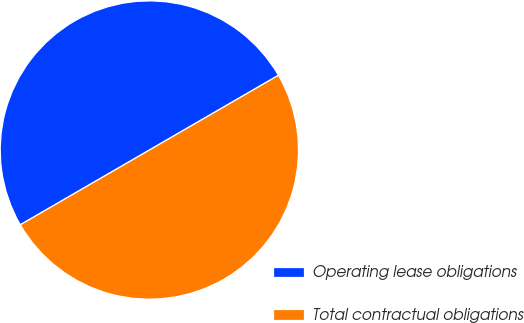<chart> <loc_0><loc_0><loc_500><loc_500><pie_chart><fcel>Operating lease obligations<fcel>Total contractual obligations<nl><fcel>50.0%<fcel>50.0%<nl></chart> 